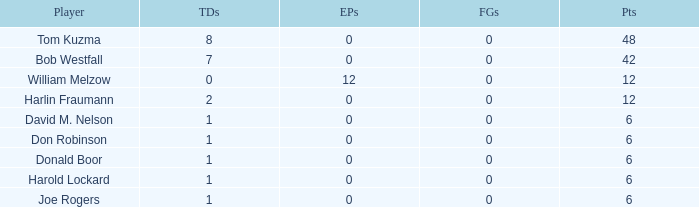Name the least touchdowns for joe rogers 1.0. 